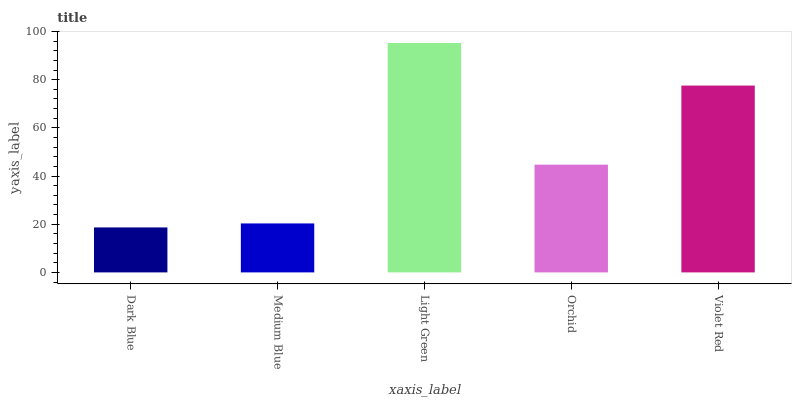Is Dark Blue the minimum?
Answer yes or no. Yes. Is Light Green the maximum?
Answer yes or no. Yes. Is Medium Blue the minimum?
Answer yes or no. No. Is Medium Blue the maximum?
Answer yes or no. No. Is Medium Blue greater than Dark Blue?
Answer yes or no. Yes. Is Dark Blue less than Medium Blue?
Answer yes or no. Yes. Is Dark Blue greater than Medium Blue?
Answer yes or no. No. Is Medium Blue less than Dark Blue?
Answer yes or no. No. Is Orchid the high median?
Answer yes or no. Yes. Is Orchid the low median?
Answer yes or no. Yes. Is Violet Red the high median?
Answer yes or no. No. Is Medium Blue the low median?
Answer yes or no. No. 